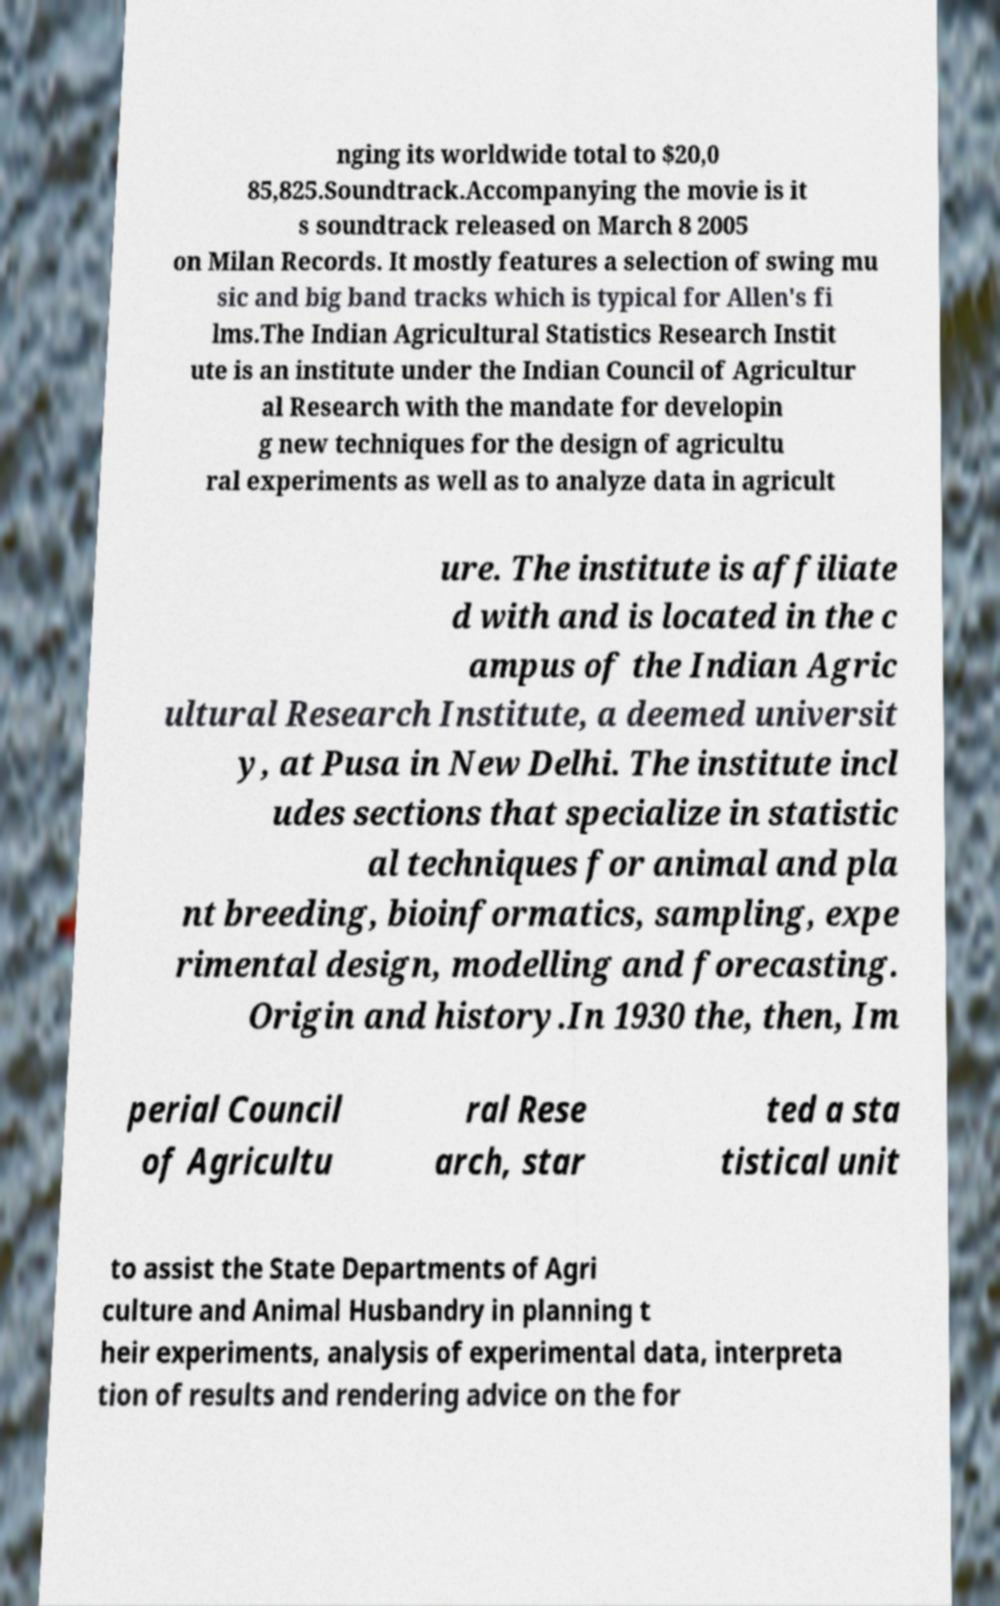Please read and relay the text visible in this image. What does it say? nging its worldwide total to $20,0 85,825.Soundtrack.Accompanying the movie is it s soundtrack released on March 8 2005 on Milan Records. It mostly features a selection of swing mu sic and big band tracks which is typical for Allen's fi lms.The Indian Agricultural Statistics Research Instit ute is an institute under the Indian Council of Agricultur al Research with the mandate for developin g new techniques for the design of agricultu ral experiments as well as to analyze data in agricult ure. The institute is affiliate d with and is located in the c ampus of the Indian Agric ultural Research Institute, a deemed universit y, at Pusa in New Delhi. The institute incl udes sections that specialize in statistic al techniques for animal and pla nt breeding, bioinformatics, sampling, expe rimental design, modelling and forecasting. Origin and history.In 1930 the, then, Im perial Council of Agricultu ral Rese arch, star ted a sta tistical unit to assist the State Departments of Agri culture and Animal Husbandry in planning t heir experiments, analysis of experimental data, interpreta tion of results and rendering advice on the for 